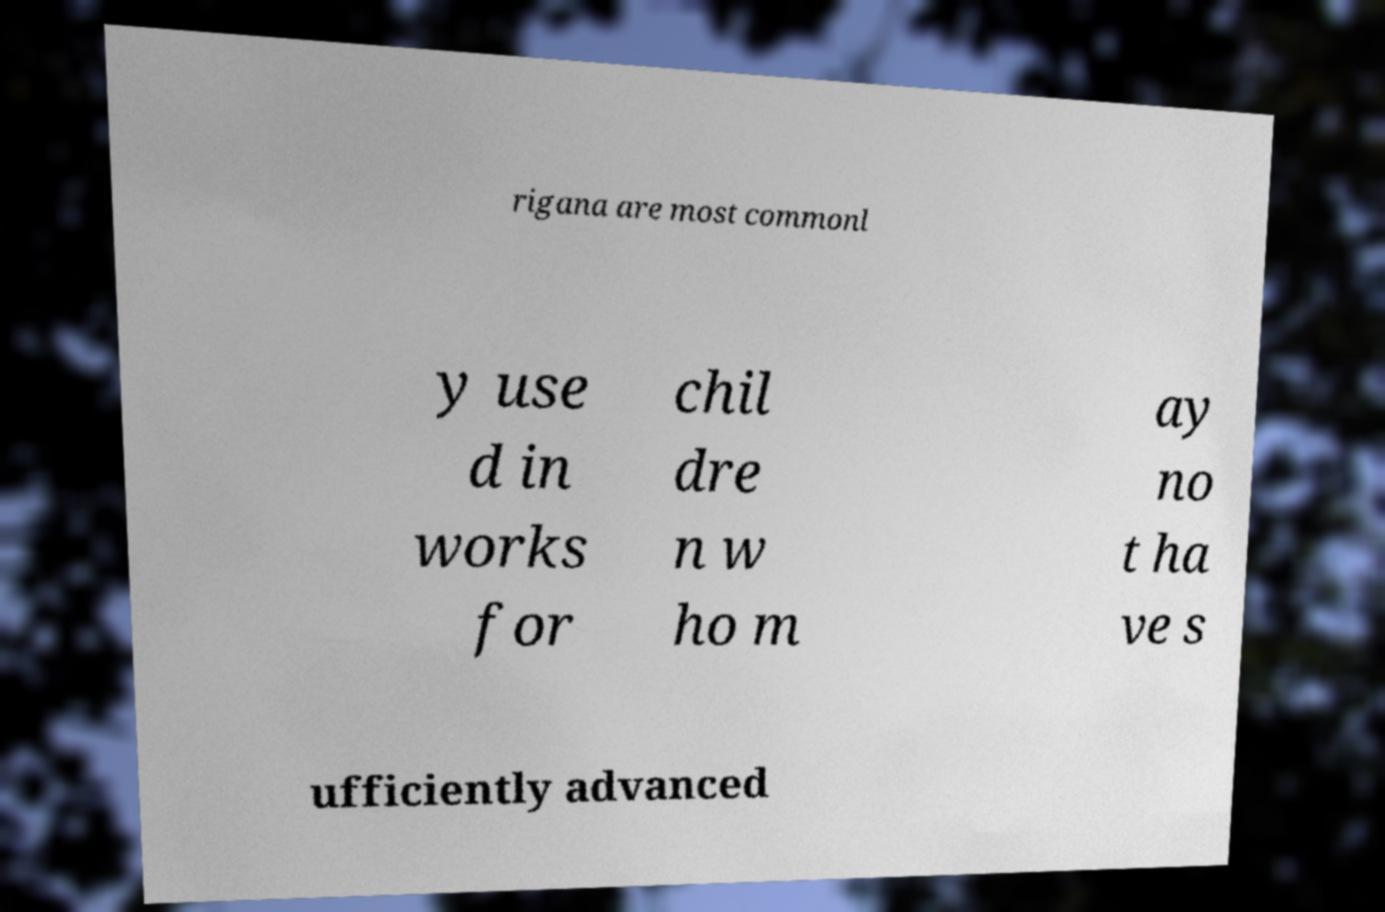Can you accurately transcribe the text from the provided image for me? rigana are most commonl y use d in works for chil dre n w ho m ay no t ha ve s ufficiently advanced 